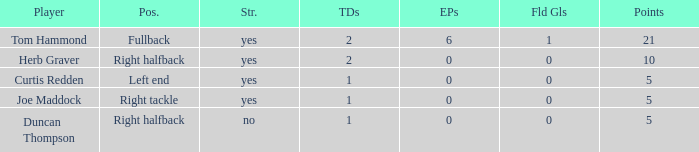Name the number of points for field goals being 1 1.0. Write the full table. {'header': ['Player', 'Pos.', 'Str.', 'TDs', 'EPs', 'Fld Gls', 'Points'], 'rows': [['Tom Hammond', 'Fullback', 'yes', '2', '6', '1', '21'], ['Herb Graver', 'Right halfback', 'yes', '2', '0', '0', '10'], ['Curtis Redden', 'Left end', 'yes', '1', '0', '0', '5'], ['Joe Maddock', 'Right tackle', 'yes', '1', '0', '0', '5'], ['Duncan Thompson', 'Right halfback', 'no', '1', '0', '0', '5']]} 